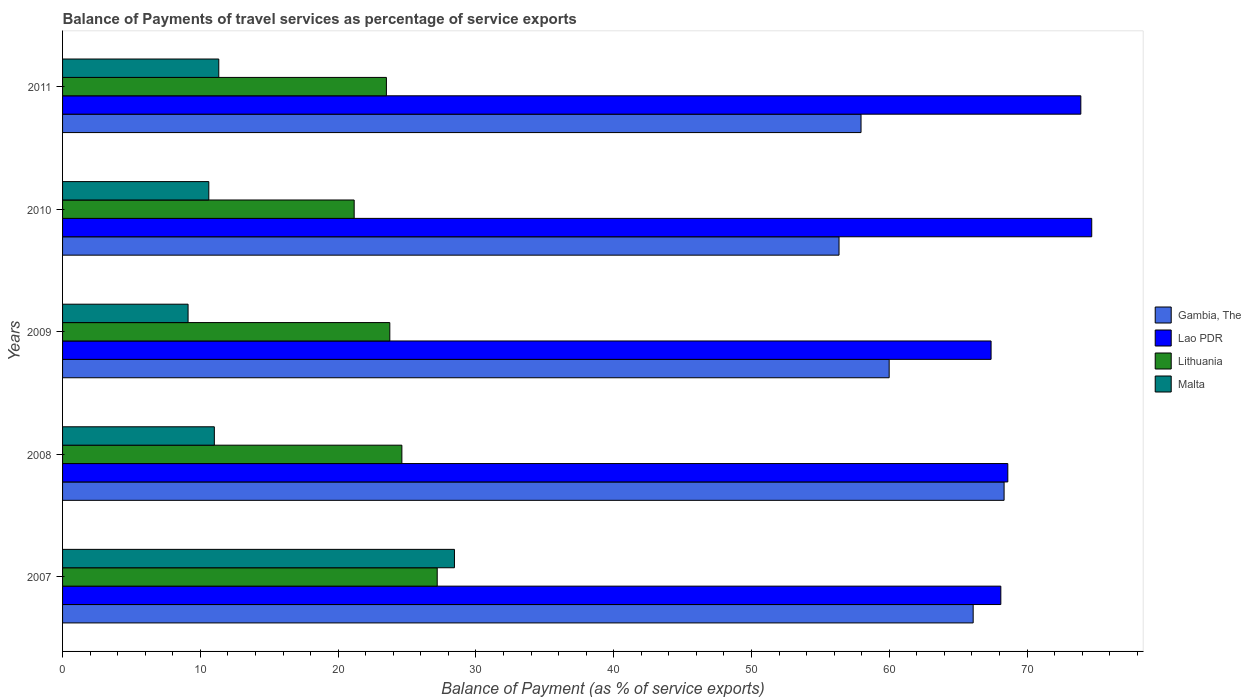How many different coloured bars are there?
Keep it short and to the point. 4. How many bars are there on the 1st tick from the bottom?
Ensure brevity in your answer.  4. What is the balance of payments of travel services in Lithuania in 2009?
Provide a short and direct response. 23.75. Across all years, what is the maximum balance of payments of travel services in Lithuania?
Provide a short and direct response. 27.19. Across all years, what is the minimum balance of payments of travel services in Malta?
Your answer should be very brief. 9.11. What is the total balance of payments of travel services in Lithuania in the graph?
Your answer should be very brief. 120.23. What is the difference between the balance of payments of travel services in Gambia, The in 2009 and that in 2010?
Provide a short and direct response. 3.64. What is the difference between the balance of payments of travel services in Gambia, The in 2008 and the balance of payments of travel services in Lithuania in 2007?
Your answer should be compact. 41.14. What is the average balance of payments of travel services in Gambia, The per year?
Provide a short and direct response. 61.74. In the year 2011, what is the difference between the balance of payments of travel services in Lithuania and balance of payments of travel services in Malta?
Offer a terse response. 12.17. In how many years, is the balance of payments of travel services in Lao PDR greater than 24 %?
Your answer should be very brief. 5. What is the ratio of the balance of payments of travel services in Malta in 2008 to that in 2010?
Provide a succinct answer. 1.04. What is the difference between the highest and the second highest balance of payments of travel services in Lao PDR?
Make the answer very short. 0.79. What is the difference between the highest and the lowest balance of payments of travel services in Malta?
Make the answer very short. 19.33. In how many years, is the balance of payments of travel services in Malta greater than the average balance of payments of travel services in Malta taken over all years?
Keep it short and to the point. 1. Is it the case that in every year, the sum of the balance of payments of travel services in Lithuania and balance of payments of travel services in Malta is greater than the sum of balance of payments of travel services in Gambia, The and balance of payments of travel services in Lao PDR?
Make the answer very short. Yes. What does the 3rd bar from the top in 2007 represents?
Provide a succinct answer. Lao PDR. What does the 2nd bar from the bottom in 2007 represents?
Offer a terse response. Lao PDR. How many bars are there?
Your answer should be compact. 20. Are all the bars in the graph horizontal?
Give a very brief answer. Yes. What is the difference between two consecutive major ticks on the X-axis?
Offer a very short reply. 10. Are the values on the major ticks of X-axis written in scientific E-notation?
Provide a short and direct response. No. Does the graph contain any zero values?
Provide a short and direct response. No. How are the legend labels stacked?
Your response must be concise. Vertical. What is the title of the graph?
Give a very brief answer. Balance of Payments of travel services as percentage of service exports. Does "Saudi Arabia" appear as one of the legend labels in the graph?
Offer a very short reply. No. What is the label or title of the X-axis?
Make the answer very short. Balance of Payment (as % of service exports). What is the Balance of Payment (as % of service exports) of Gambia, The in 2007?
Ensure brevity in your answer.  66.09. What is the Balance of Payment (as % of service exports) in Lao PDR in 2007?
Your answer should be compact. 68.09. What is the Balance of Payment (as % of service exports) in Lithuania in 2007?
Your response must be concise. 27.19. What is the Balance of Payment (as % of service exports) of Malta in 2007?
Your response must be concise. 28.44. What is the Balance of Payment (as % of service exports) in Gambia, The in 2008?
Keep it short and to the point. 68.33. What is the Balance of Payment (as % of service exports) of Lao PDR in 2008?
Give a very brief answer. 68.6. What is the Balance of Payment (as % of service exports) of Lithuania in 2008?
Your answer should be compact. 24.62. What is the Balance of Payment (as % of service exports) of Malta in 2008?
Make the answer very short. 11.02. What is the Balance of Payment (as % of service exports) in Gambia, The in 2009?
Offer a very short reply. 59.99. What is the Balance of Payment (as % of service exports) in Lao PDR in 2009?
Your answer should be compact. 67.39. What is the Balance of Payment (as % of service exports) in Lithuania in 2009?
Make the answer very short. 23.75. What is the Balance of Payment (as % of service exports) of Malta in 2009?
Ensure brevity in your answer.  9.11. What is the Balance of Payment (as % of service exports) of Gambia, The in 2010?
Make the answer very short. 56.35. What is the Balance of Payment (as % of service exports) of Lao PDR in 2010?
Provide a short and direct response. 74.69. What is the Balance of Payment (as % of service exports) of Lithuania in 2010?
Give a very brief answer. 21.16. What is the Balance of Payment (as % of service exports) in Malta in 2010?
Make the answer very short. 10.61. What is the Balance of Payment (as % of service exports) in Gambia, The in 2011?
Offer a very short reply. 57.95. What is the Balance of Payment (as % of service exports) in Lao PDR in 2011?
Offer a very short reply. 73.9. What is the Balance of Payment (as % of service exports) of Lithuania in 2011?
Give a very brief answer. 23.5. What is the Balance of Payment (as % of service exports) of Malta in 2011?
Ensure brevity in your answer.  11.34. Across all years, what is the maximum Balance of Payment (as % of service exports) in Gambia, The?
Offer a very short reply. 68.33. Across all years, what is the maximum Balance of Payment (as % of service exports) of Lao PDR?
Provide a succinct answer. 74.69. Across all years, what is the maximum Balance of Payment (as % of service exports) in Lithuania?
Your response must be concise. 27.19. Across all years, what is the maximum Balance of Payment (as % of service exports) of Malta?
Your answer should be very brief. 28.44. Across all years, what is the minimum Balance of Payment (as % of service exports) in Gambia, The?
Make the answer very short. 56.35. Across all years, what is the minimum Balance of Payment (as % of service exports) of Lao PDR?
Your response must be concise. 67.39. Across all years, what is the minimum Balance of Payment (as % of service exports) in Lithuania?
Your answer should be compact. 21.16. Across all years, what is the minimum Balance of Payment (as % of service exports) of Malta?
Keep it short and to the point. 9.11. What is the total Balance of Payment (as % of service exports) of Gambia, The in the graph?
Provide a succinct answer. 308.71. What is the total Balance of Payment (as % of service exports) of Lao PDR in the graph?
Make the answer very short. 352.67. What is the total Balance of Payment (as % of service exports) of Lithuania in the graph?
Give a very brief answer. 120.23. What is the total Balance of Payment (as % of service exports) of Malta in the graph?
Provide a succinct answer. 70.52. What is the difference between the Balance of Payment (as % of service exports) of Gambia, The in 2007 and that in 2008?
Your answer should be very brief. -2.24. What is the difference between the Balance of Payment (as % of service exports) of Lao PDR in 2007 and that in 2008?
Offer a terse response. -0.51. What is the difference between the Balance of Payment (as % of service exports) of Lithuania in 2007 and that in 2008?
Offer a very short reply. 2.57. What is the difference between the Balance of Payment (as % of service exports) of Malta in 2007 and that in 2008?
Give a very brief answer. 17.43. What is the difference between the Balance of Payment (as % of service exports) in Gambia, The in 2007 and that in 2009?
Give a very brief answer. 6.1. What is the difference between the Balance of Payment (as % of service exports) of Lao PDR in 2007 and that in 2009?
Provide a succinct answer. 0.71. What is the difference between the Balance of Payment (as % of service exports) of Lithuania in 2007 and that in 2009?
Offer a terse response. 3.44. What is the difference between the Balance of Payment (as % of service exports) in Malta in 2007 and that in 2009?
Ensure brevity in your answer.  19.33. What is the difference between the Balance of Payment (as % of service exports) of Gambia, The in 2007 and that in 2010?
Your answer should be compact. 9.73. What is the difference between the Balance of Payment (as % of service exports) of Lao PDR in 2007 and that in 2010?
Offer a terse response. -6.6. What is the difference between the Balance of Payment (as % of service exports) of Lithuania in 2007 and that in 2010?
Your response must be concise. 6.03. What is the difference between the Balance of Payment (as % of service exports) of Malta in 2007 and that in 2010?
Give a very brief answer. 17.83. What is the difference between the Balance of Payment (as % of service exports) in Gambia, The in 2007 and that in 2011?
Provide a succinct answer. 8.14. What is the difference between the Balance of Payment (as % of service exports) of Lao PDR in 2007 and that in 2011?
Provide a short and direct response. -5.81. What is the difference between the Balance of Payment (as % of service exports) of Lithuania in 2007 and that in 2011?
Your answer should be very brief. 3.69. What is the difference between the Balance of Payment (as % of service exports) in Malta in 2007 and that in 2011?
Your answer should be compact. 17.1. What is the difference between the Balance of Payment (as % of service exports) of Gambia, The in 2008 and that in 2009?
Make the answer very short. 8.34. What is the difference between the Balance of Payment (as % of service exports) of Lao PDR in 2008 and that in 2009?
Give a very brief answer. 1.21. What is the difference between the Balance of Payment (as % of service exports) in Lithuania in 2008 and that in 2009?
Offer a very short reply. 0.88. What is the difference between the Balance of Payment (as % of service exports) of Malta in 2008 and that in 2009?
Make the answer very short. 1.91. What is the difference between the Balance of Payment (as % of service exports) in Gambia, The in 2008 and that in 2010?
Make the answer very short. 11.98. What is the difference between the Balance of Payment (as % of service exports) of Lao PDR in 2008 and that in 2010?
Your answer should be compact. -6.09. What is the difference between the Balance of Payment (as % of service exports) of Lithuania in 2008 and that in 2010?
Provide a short and direct response. 3.46. What is the difference between the Balance of Payment (as % of service exports) in Malta in 2008 and that in 2010?
Your response must be concise. 0.4. What is the difference between the Balance of Payment (as % of service exports) in Gambia, The in 2008 and that in 2011?
Your answer should be compact. 10.38. What is the difference between the Balance of Payment (as % of service exports) of Lao PDR in 2008 and that in 2011?
Give a very brief answer. -5.3. What is the difference between the Balance of Payment (as % of service exports) in Lithuania in 2008 and that in 2011?
Your answer should be very brief. 1.12. What is the difference between the Balance of Payment (as % of service exports) of Malta in 2008 and that in 2011?
Keep it short and to the point. -0.32. What is the difference between the Balance of Payment (as % of service exports) in Gambia, The in 2009 and that in 2010?
Your answer should be compact. 3.64. What is the difference between the Balance of Payment (as % of service exports) of Lao PDR in 2009 and that in 2010?
Ensure brevity in your answer.  -7.31. What is the difference between the Balance of Payment (as % of service exports) in Lithuania in 2009 and that in 2010?
Provide a short and direct response. 2.59. What is the difference between the Balance of Payment (as % of service exports) of Malta in 2009 and that in 2010?
Ensure brevity in your answer.  -1.51. What is the difference between the Balance of Payment (as % of service exports) in Gambia, The in 2009 and that in 2011?
Keep it short and to the point. 2.04. What is the difference between the Balance of Payment (as % of service exports) of Lao PDR in 2009 and that in 2011?
Offer a terse response. -6.51. What is the difference between the Balance of Payment (as % of service exports) in Lithuania in 2009 and that in 2011?
Make the answer very short. 0.25. What is the difference between the Balance of Payment (as % of service exports) of Malta in 2009 and that in 2011?
Your answer should be very brief. -2.23. What is the difference between the Balance of Payment (as % of service exports) in Gambia, The in 2010 and that in 2011?
Make the answer very short. -1.6. What is the difference between the Balance of Payment (as % of service exports) in Lao PDR in 2010 and that in 2011?
Provide a succinct answer. 0.79. What is the difference between the Balance of Payment (as % of service exports) of Lithuania in 2010 and that in 2011?
Make the answer very short. -2.34. What is the difference between the Balance of Payment (as % of service exports) of Malta in 2010 and that in 2011?
Your answer should be very brief. -0.72. What is the difference between the Balance of Payment (as % of service exports) of Gambia, The in 2007 and the Balance of Payment (as % of service exports) of Lao PDR in 2008?
Give a very brief answer. -2.51. What is the difference between the Balance of Payment (as % of service exports) in Gambia, The in 2007 and the Balance of Payment (as % of service exports) in Lithuania in 2008?
Provide a short and direct response. 41.46. What is the difference between the Balance of Payment (as % of service exports) in Gambia, The in 2007 and the Balance of Payment (as % of service exports) in Malta in 2008?
Provide a short and direct response. 55.07. What is the difference between the Balance of Payment (as % of service exports) of Lao PDR in 2007 and the Balance of Payment (as % of service exports) of Lithuania in 2008?
Make the answer very short. 43.47. What is the difference between the Balance of Payment (as % of service exports) in Lao PDR in 2007 and the Balance of Payment (as % of service exports) in Malta in 2008?
Provide a succinct answer. 57.08. What is the difference between the Balance of Payment (as % of service exports) of Lithuania in 2007 and the Balance of Payment (as % of service exports) of Malta in 2008?
Keep it short and to the point. 16.18. What is the difference between the Balance of Payment (as % of service exports) in Gambia, The in 2007 and the Balance of Payment (as % of service exports) in Lao PDR in 2009?
Your answer should be very brief. -1.3. What is the difference between the Balance of Payment (as % of service exports) of Gambia, The in 2007 and the Balance of Payment (as % of service exports) of Lithuania in 2009?
Make the answer very short. 42.34. What is the difference between the Balance of Payment (as % of service exports) of Gambia, The in 2007 and the Balance of Payment (as % of service exports) of Malta in 2009?
Provide a succinct answer. 56.98. What is the difference between the Balance of Payment (as % of service exports) in Lao PDR in 2007 and the Balance of Payment (as % of service exports) in Lithuania in 2009?
Your answer should be compact. 44.34. What is the difference between the Balance of Payment (as % of service exports) in Lao PDR in 2007 and the Balance of Payment (as % of service exports) in Malta in 2009?
Make the answer very short. 58.99. What is the difference between the Balance of Payment (as % of service exports) of Lithuania in 2007 and the Balance of Payment (as % of service exports) of Malta in 2009?
Make the answer very short. 18.08. What is the difference between the Balance of Payment (as % of service exports) of Gambia, The in 2007 and the Balance of Payment (as % of service exports) of Lao PDR in 2010?
Offer a very short reply. -8.61. What is the difference between the Balance of Payment (as % of service exports) in Gambia, The in 2007 and the Balance of Payment (as % of service exports) in Lithuania in 2010?
Your response must be concise. 44.92. What is the difference between the Balance of Payment (as % of service exports) of Gambia, The in 2007 and the Balance of Payment (as % of service exports) of Malta in 2010?
Give a very brief answer. 55.47. What is the difference between the Balance of Payment (as % of service exports) in Lao PDR in 2007 and the Balance of Payment (as % of service exports) in Lithuania in 2010?
Provide a succinct answer. 46.93. What is the difference between the Balance of Payment (as % of service exports) in Lao PDR in 2007 and the Balance of Payment (as % of service exports) in Malta in 2010?
Offer a terse response. 57.48. What is the difference between the Balance of Payment (as % of service exports) of Lithuania in 2007 and the Balance of Payment (as % of service exports) of Malta in 2010?
Keep it short and to the point. 16.58. What is the difference between the Balance of Payment (as % of service exports) of Gambia, The in 2007 and the Balance of Payment (as % of service exports) of Lao PDR in 2011?
Give a very brief answer. -7.81. What is the difference between the Balance of Payment (as % of service exports) in Gambia, The in 2007 and the Balance of Payment (as % of service exports) in Lithuania in 2011?
Make the answer very short. 42.58. What is the difference between the Balance of Payment (as % of service exports) in Gambia, The in 2007 and the Balance of Payment (as % of service exports) in Malta in 2011?
Offer a very short reply. 54.75. What is the difference between the Balance of Payment (as % of service exports) of Lao PDR in 2007 and the Balance of Payment (as % of service exports) of Lithuania in 2011?
Give a very brief answer. 44.59. What is the difference between the Balance of Payment (as % of service exports) in Lao PDR in 2007 and the Balance of Payment (as % of service exports) in Malta in 2011?
Give a very brief answer. 56.76. What is the difference between the Balance of Payment (as % of service exports) in Lithuania in 2007 and the Balance of Payment (as % of service exports) in Malta in 2011?
Ensure brevity in your answer.  15.85. What is the difference between the Balance of Payment (as % of service exports) of Gambia, The in 2008 and the Balance of Payment (as % of service exports) of Lao PDR in 2009?
Keep it short and to the point. 0.94. What is the difference between the Balance of Payment (as % of service exports) in Gambia, The in 2008 and the Balance of Payment (as % of service exports) in Lithuania in 2009?
Make the answer very short. 44.58. What is the difference between the Balance of Payment (as % of service exports) of Gambia, The in 2008 and the Balance of Payment (as % of service exports) of Malta in 2009?
Give a very brief answer. 59.22. What is the difference between the Balance of Payment (as % of service exports) in Lao PDR in 2008 and the Balance of Payment (as % of service exports) in Lithuania in 2009?
Keep it short and to the point. 44.85. What is the difference between the Balance of Payment (as % of service exports) of Lao PDR in 2008 and the Balance of Payment (as % of service exports) of Malta in 2009?
Your answer should be very brief. 59.49. What is the difference between the Balance of Payment (as % of service exports) in Lithuania in 2008 and the Balance of Payment (as % of service exports) in Malta in 2009?
Your answer should be very brief. 15.52. What is the difference between the Balance of Payment (as % of service exports) of Gambia, The in 2008 and the Balance of Payment (as % of service exports) of Lao PDR in 2010?
Give a very brief answer. -6.36. What is the difference between the Balance of Payment (as % of service exports) of Gambia, The in 2008 and the Balance of Payment (as % of service exports) of Lithuania in 2010?
Your answer should be compact. 47.17. What is the difference between the Balance of Payment (as % of service exports) of Gambia, The in 2008 and the Balance of Payment (as % of service exports) of Malta in 2010?
Offer a very short reply. 57.72. What is the difference between the Balance of Payment (as % of service exports) of Lao PDR in 2008 and the Balance of Payment (as % of service exports) of Lithuania in 2010?
Your response must be concise. 47.44. What is the difference between the Balance of Payment (as % of service exports) of Lao PDR in 2008 and the Balance of Payment (as % of service exports) of Malta in 2010?
Your response must be concise. 57.99. What is the difference between the Balance of Payment (as % of service exports) in Lithuania in 2008 and the Balance of Payment (as % of service exports) in Malta in 2010?
Give a very brief answer. 14.01. What is the difference between the Balance of Payment (as % of service exports) in Gambia, The in 2008 and the Balance of Payment (as % of service exports) in Lao PDR in 2011?
Your answer should be compact. -5.57. What is the difference between the Balance of Payment (as % of service exports) in Gambia, The in 2008 and the Balance of Payment (as % of service exports) in Lithuania in 2011?
Ensure brevity in your answer.  44.83. What is the difference between the Balance of Payment (as % of service exports) of Gambia, The in 2008 and the Balance of Payment (as % of service exports) of Malta in 2011?
Ensure brevity in your answer.  56.99. What is the difference between the Balance of Payment (as % of service exports) of Lao PDR in 2008 and the Balance of Payment (as % of service exports) of Lithuania in 2011?
Ensure brevity in your answer.  45.1. What is the difference between the Balance of Payment (as % of service exports) of Lao PDR in 2008 and the Balance of Payment (as % of service exports) of Malta in 2011?
Offer a very short reply. 57.26. What is the difference between the Balance of Payment (as % of service exports) of Lithuania in 2008 and the Balance of Payment (as % of service exports) of Malta in 2011?
Your response must be concise. 13.29. What is the difference between the Balance of Payment (as % of service exports) of Gambia, The in 2009 and the Balance of Payment (as % of service exports) of Lao PDR in 2010?
Offer a very short reply. -14.7. What is the difference between the Balance of Payment (as % of service exports) in Gambia, The in 2009 and the Balance of Payment (as % of service exports) in Lithuania in 2010?
Offer a very short reply. 38.83. What is the difference between the Balance of Payment (as % of service exports) in Gambia, The in 2009 and the Balance of Payment (as % of service exports) in Malta in 2010?
Offer a terse response. 49.38. What is the difference between the Balance of Payment (as % of service exports) of Lao PDR in 2009 and the Balance of Payment (as % of service exports) of Lithuania in 2010?
Provide a short and direct response. 46.22. What is the difference between the Balance of Payment (as % of service exports) of Lao PDR in 2009 and the Balance of Payment (as % of service exports) of Malta in 2010?
Offer a terse response. 56.77. What is the difference between the Balance of Payment (as % of service exports) in Lithuania in 2009 and the Balance of Payment (as % of service exports) in Malta in 2010?
Provide a succinct answer. 13.14. What is the difference between the Balance of Payment (as % of service exports) of Gambia, The in 2009 and the Balance of Payment (as % of service exports) of Lao PDR in 2011?
Ensure brevity in your answer.  -13.91. What is the difference between the Balance of Payment (as % of service exports) of Gambia, The in 2009 and the Balance of Payment (as % of service exports) of Lithuania in 2011?
Your response must be concise. 36.49. What is the difference between the Balance of Payment (as % of service exports) in Gambia, The in 2009 and the Balance of Payment (as % of service exports) in Malta in 2011?
Your response must be concise. 48.65. What is the difference between the Balance of Payment (as % of service exports) in Lao PDR in 2009 and the Balance of Payment (as % of service exports) in Lithuania in 2011?
Keep it short and to the point. 43.88. What is the difference between the Balance of Payment (as % of service exports) of Lao PDR in 2009 and the Balance of Payment (as % of service exports) of Malta in 2011?
Your answer should be compact. 56.05. What is the difference between the Balance of Payment (as % of service exports) in Lithuania in 2009 and the Balance of Payment (as % of service exports) in Malta in 2011?
Provide a short and direct response. 12.41. What is the difference between the Balance of Payment (as % of service exports) in Gambia, The in 2010 and the Balance of Payment (as % of service exports) in Lao PDR in 2011?
Give a very brief answer. -17.55. What is the difference between the Balance of Payment (as % of service exports) in Gambia, The in 2010 and the Balance of Payment (as % of service exports) in Lithuania in 2011?
Offer a terse response. 32.85. What is the difference between the Balance of Payment (as % of service exports) in Gambia, The in 2010 and the Balance of Payment (as % of service exports) in Malta in 2011?
Keep it short and to the point. 45.01. What is the difference between the Balance of Payment (as % of service exports) in Lao PDR in 2010 and the Balance of Payment (as % of service exports) in Lithuania in 2011?
Offer a very short reply. 51.19. What is the difference between the Balance of Payment (as % of service exports) of Lao PDR in 2010 and the Balance of Payment (as % of service exports) of Malta in 2011?
Give a very brief answer. 63.35. What is the difference between the Balance of Payment (as % of service exports) in Lithuania in 2010 and the Balance of Payment (as % of service exports) in Malta in 2011?
Offer a very short reply. 9.83. What is the average Balance of Payment (as % of service exports) in Gambia, The per year?
Your answer should be very brief. 61.74. What is the average Balance of Payment (as % of service exports) in Lao PDR per year?
Your answer should be compact. 70.53. What is the average Balance of Payment (as % of service exports) of Lithuania per year?
Offer a terse response. 24.05. What is the average Balance of Payment (as % of service exports) in Malta per year?
Your response must be concise. 14.1. In the year 2007, what is the difference between the Balance of Payment (as % of service exports) of Gambia, The and Balance of Payment (as % of service exports) of Lao PDR?
Your response must be concise. -2.01. In the year 2007, what is the difference between the Balance of Payment (as % of service exports) of Gambia, The and Balance of Payment (as % of service exports) of Lithuania?
Make the answer very short. 38.9. In the year 2007, what is the difference between the Balance of Payment (as % of service exports) in Gambia, The and Balance of Payment (as % of service exports) in Malta?
Keep it short and to the point. 37.65. In the year 2007, what is the difference between the Balance of Payment (as % of service exports) in Lao PDR and Balance of Payment (as % of service exports) in Lithuania?
Provide a short and direct response. 40.9. In the year 2007, what is the difference between the Balance of Payment (as % of service exports) of Lao PDR and Balance of Payment (as % of service exports) of Malta?
Provide a succinct answer. 39.65. In the year 2007, what is the difference between the Balance of Payment (as % of service exports) of Lithuania and Balance of Payment (as % of service exports) of Malta?
Your answer should be very brief. -1.25. In the year 2008, what is the difference between the Balance of Payment (as % of service exports) of Gambia, The and Balance of Payment (as % of service exports) of Lao PDR?
Your answer should be compact. -0.27. In the year 2008, what is the difference between the Balance of Payment (as % of service exports) in Gambia, The and Balance of Payment (as % of service exports) in Lithuania?
Offer a terse response. 43.71. In the year 2008, what is the difference between the Balance of Payment (as % of service exports) of Gambia, The and Balance of Payment (as % of service exports) of Malta?
Keep it short and to the point. 57.32. In the year 2008, what is the difference between the Balance of Payment (as % of service exports) of Lao PDR and Balance of Payment (as % of service exports) of Lithuania?
Keep it short and to the point. 43.98. In the year 2008, what is the difference between the Balance of Payment (as % of service exports) of Lao PDR and Balance of Payment (as % of service exports) of Malta?
Your answer should be compact. 57.58. In the year 2008, what is the difference between the Balance of Payment (as % of service exports) of Lithuania and Balance of Payment (as % of service exports) of Malta?
Your response must be concise. 13.61. In the year 2009, what is the difference between the Balance of Payment (as % of service exports) in Gambia, The and Balance of Payment (as % of service exports) in Lao PDR?
Make the answer very short. -7.4. In the year 2009, what is the difference between the Balance of Payment (as % of service exports) of Gambia, The and Balance of Payment (as % of service exports) of Lithuania?
Provide a short and direct response. 36.24. In the year 2009, what is the difference between the Balance of Payment (as % of service exports) in Gambia, The and Balance of Payment (as % of service exports) in Malta?
Make the answer very short. 50.88. In the year 2009, what is the difference between the Balance of Payment (as % of service exports) in Lao PDR and Balance of Payment (as % of service exports) in Lithuania?
Your response must be concise. 43.64. In the year 2009, what is the difference between the Balance of Payment (as % of service exports) of Lao PDR and Balance of Payment (as % of service exports) of Malta?
Make the answer very short. 58.28. In the year 2009, what is the difference between the Balance of Payment (as % of service exports) in Lithuania and Balance of Payment (as % of service exports) in Malta?
Offer a terse response. 14.64. In the year 2010, what is the difference between the Balance of Payment (as % of service exports) of Gambia, The and Balance of Payment (as % of service exports) of Lao PDR?
Ensure brevity in your answer.  -18.34. In the year 2010, what is the difference between the Balance of Payment (as % of service exports) in Gambia, The and Balance of Payment (as % of service exports) in Lithuania?
Provide a succinct answer. 35.19. In the year 2010, what is the difference between the Balance of Payment (as % of service exports) of Gambia, The and Balance of Payment (as % of service exports) of Malta?
Offer a terse response. 45.74. In the year 2010, what is the difference between the Balance of Payment (as % of service exports) of Lao PDR and Balance of Payment (as % of service exports) of Lithuania?
Make the answer very short. 53.53. In the year 2010, what is the difference between the Balance of Payment (as % of service exports) in Lao PDR and Balance of Payment (as % of service exports) in Malta?
Make the answer very short. 64.08. In the year 2010, what is the difference between the Balance of Payment (as % of service exports) in Lithuania and Balance of Payment (as % of service exports) in Malta?
Provide a short and direct response. 10.55. In the year 2011, what is the difference between the Balance of Payment (as % of service exports) in Gambia, The and Balance of Payment (as % of service exports) in Lao PDR?
Ensure brevity in your answer.  -15.95. In the year 2011, what is the difference between the Balance of Payment (as % of service exports) of Gambia, The and Balance of Payment (as % of service exports) of Lithuania?
Your answer should be very brief. 34.45. In the year 2011, what is the difference between the Balance of Payment (as % of service exports) in Gambia, The and Balance of Payment (as % of service exports) in Malta?
Provide a succinct answer. 46.61. In the year 2011, what is the difference between the Balance of Payment (as % of service exports) in Lao PDR and Balance of Payment (as % of service exports) in Lithuania?
Offer a very short reply. 50.4. In the year 2011, what is the difference between the Balance of Payment (as % of service exports) in Lao PDR and Balance of Payment (as % of service exports) in Malta?
Give a very brief answer. 62.56. In the year 2011, what is the difference between the Balance of Payment (as % of service exports) in Lithuania and Balance of Payment (as % of service exports) in Malta?
Offer a very short reply. 12.17. What is the ratio of the Balance of Payment (as % of service exports) in Gambia, The in 2007 to that in 2008?
Offer a very short reply. 0.97. What is the ratio of the Balance of Payment (as % of service exports) of Lithuania in 2007 to that in 2008?
Your answer should be very brief. 1.1. What is the ratio of the Balance of Payment (as % of service exports) in Malta in 2007 to that in 2008?
Provide a succinct answer. 2.58. What is the ratio of the Balance of Payment (as % of service exports) in Gambia, The in 2007 to that in 2009?
Your answer should be compact. 1.1. What is the ratio of the Balance of Payment (as % of service exports) in Lao PDR in 2007 to that in 2009?
Provide a succinct answer. 1.01. What is the ratio of the Balance of Payment (as % of service exports) in Lithuania in 2007 to that in 2009?
Make the answer very short. 1.14. What is the ratio of the Balance of Payment (as % of service exports) of Malta in 2007 to that in 2009?
Your answer should be very brief. 3.12. What is the ratio of the Balance of Payment (as % of service exports) of Gambia, The in 2007 to that in 2010?
Keep it short and to the point. 1.17. What is the ratio of the Balance of Payment (as % of service exports) of Lao PDR in 2007 to that in 2010?
Your response must be concise. 0.91. What is the ratio of the Balance of Payment (as % of service exports) in Lithuania in 2007 to that in 2010?
Your answer should be compact. 1.28. What is the ratio of the Balance of Payment (as % of service exports) in Malta in 2007 to that in 2010?
Make the answer very short. 2.68. What is the ratio of the Balance of Payment (as % of service exports) of Gambia, The in 2007 to that in 2011?
Your answer should be compact. 1.14. What is the ratio of the Balance of Payment (as % of service exports) of Lao PDR in 2007 to that in 2011?
Your answer should be compact. 0.92. What is the ratio of the Balance of Payment (as % of service exports) of Lithuania in 2007 to that in 2011?
Give a very brief answer. 1.16. What is the ratio of the Balance of Payment (as % of service exports) in Malta in 2007 to that in 2011?
Your response must be concise. 2.51. What is the ratio of the Balance of Payment (as % of service exports) of Gambia, The in 2008 to that in 2009?
Keep it short and to the point. 1.14. What is the ratio of the Balance of Payment (as % of service exports) in Lao PDR in 2008 to that in 2009?
Keep it short and to the point. 1.02. What is the ratio of the Balance of Payment (as % of service exports) of Lithuania in 2008 to that in 2009?
Your answer should be compact. 1.04. What is the ratio of the Balance of Payment (as % of service exports) in Malta in 2008 to that in 2009?
Your response must be concise. 1.21. What is the ratio of the Balance of Payment (as % of service exports) in Gambia, The in 2008 to that in 2010?
Ensure brevity in your answer.  1.21. What is the ratio of the Balance of Payment (as % of service exports) in Lao PDR in 2008 to that in 2010?
Your answer should be very brief. 0.92. What is the ratio of the Balance of Payment (as % of service exports) of Lithuania in 2008 to that in 2010?
Keep it short and to the point. 1.16. What is the ratio of the Balance of Payment (as % of service exports) of Malta in 2008 to that in 2010?
Make the answer very short. 1.04. What is the ratio of the Balance of Payment (as % of service exports) of Gambia, The in 2008 to that in 2011?
Offer a terse response. 1.18. What is the ratio of the Balance of Payment (as % of service exports) of Lao PDR in 2008 to that in 2011?
Keep it short and to the point. 0.93. What is the ratio of the Balance of Payment (as % of service exports) of Lithuania in 2008 to that in 2011?
Make the answer very short. 1.05. What is the ratio of the Balance of Payment (as % of service exports) of Malta in 2008 to that in 2011?
Provide a short and direct response. 0.97. What is the ratio of the Balance of Payment (as % of service exports) of Gambia, The in 2009 to that in 2010?
Give a very brief answer. 1.06. What is the ratio of the Balance of Payment (as % of service exports) in Lao PDR in 2009 to that in 2010?
Ensure brevity in your answer.  0.9. What is the ratio of the Balance of Payment (as % of service exports) in Lithuania in 2009 to that in 2010?
Your answer should be compact. 1.12. What is the ratio of the Balance of Payment (as % of service exports) of Malta in 2009 to that in 2010?
Provide a succinct answer. 0.86. What is the ratio of the Balance of Payment (as % of service exports) in Gambia, The in 2009 to that in 2011?
Provide a succinct answer. 1.04. What is the ratio of the Balance of Payment (as % of service exports) of Lao PDR in 2009 to that in 2011?
Offer a very short reply. 0.91. What is the ratio of the Balance of Payment (as % of service exports) of Lithuania in 2009 to that in 2011?
Provide a short and direct response. 1.01. What is the ratio of the Balance of Payment (as % of service exports) of Malta in 2009 to that in 2011?
Your response must be concise. 0.8. What is the ratio of the Balance of Payment (as % of service exports) of Gambia, The in 2010 to that in 2011?
Offer a terse response. 0.97. What is the ratio of the Balance of Payment (as % of service exports) of Lao PDR in 2010 to that in 2011?
Provide a short and direct response. 1.01. What is the ratio of the Balance of Payment (as % of service exports) in Lithuania in 2010 to that in 2011?
Your response must be concise. 0.9. What is the ratio of the Balance of Payment (as % of service exports) in Malta in 2010 to that in 2011?
Your answer should be very brief. 0.94. What is the difference between the highest and the second highest Balance of Payment (as % of service exports) of Gambia, The?
Your answer should be compact. 2.24. What is the difference between the highest and the second highest Balance of Payment (as % of service exports) in Lao PDR?
Give a very brief answer. 0.79. What is the difference between the highest and the second highest Balance of Payment (as % of service exports) in Lithuania?
Offer a terse response. 2.57. What is the difference between the highest and the second highest Balance of Payment (as % of service exports) of Malta?
Your response must be concise. 17.1. What is the difference between the highest and the lowest Balance of Payment (as % of service exports) of Gambia, The?
Offer a very short reply. 11.98. What is the difference between the highest and the lowest Balance of Payment (as % of service exports) of Lao PDR?
Make the answer very short. 7.31. What is the difference between the highest and the lowest Balance of Payment (as % of service exports) of Lithuania?
Give a very brief answer. 6.03. What is the difference between the highest and the lowest Balance of Payment (as % of service exports) in Malta?
Make the answer very short. 19.33. 